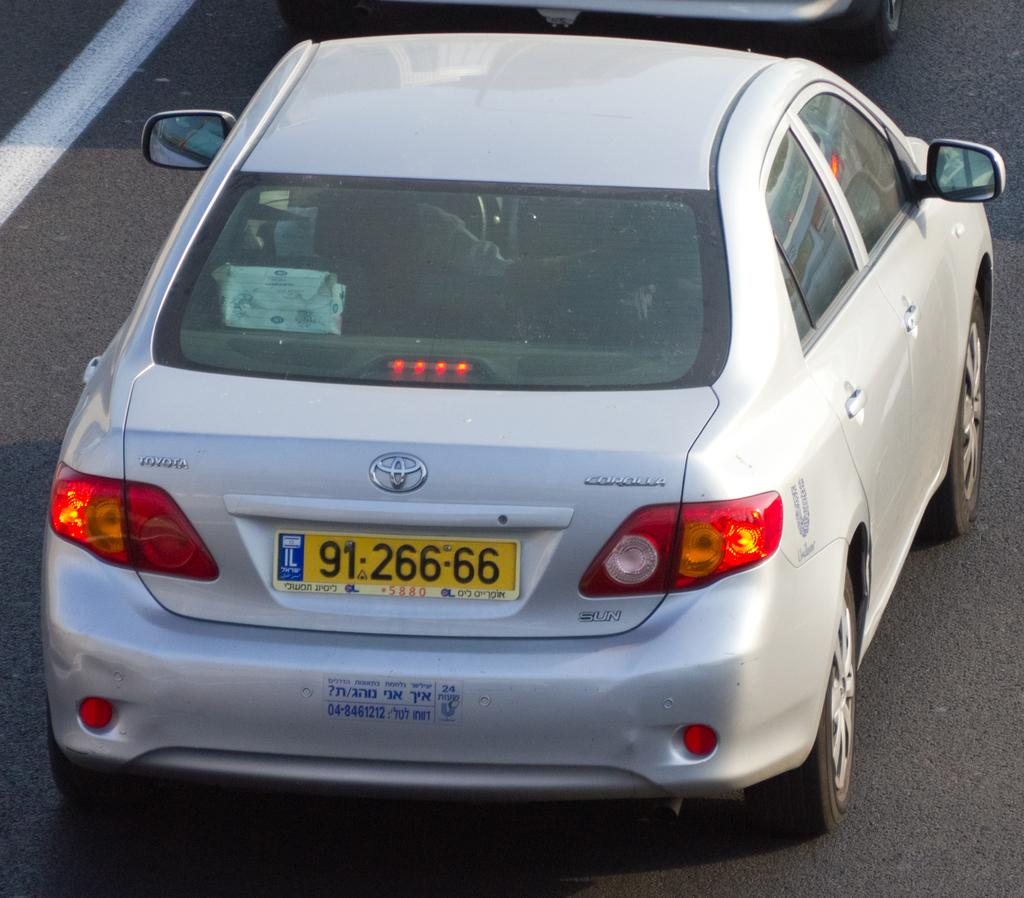<image>
Relay a brief, clear account of the picture shown. A Toyota vehicle has a license plate on it reading 91 266 66. 